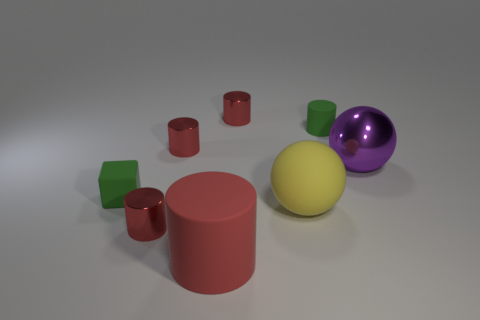Subtract all matte cylinders. How many cylinders are left? 3 Add 1 cyan rubber balls. How many objects exist? 9 Subtract all green cylinders. How many cylinders are left? 4 Subtract all brown spheres. How many red cylinders are left? 4 Subtract 4 cylinders. How many cylinders are left? 1 Subtract all green cylinders. Subtract all gray blocks. How many cylinders are left? 4 Subtract all big green matte blocks. Subtract all yellow rubber balls. How many objects are left? 7 Add 1 big yellow matte things. How many big yellow matte things are left? 2 Add 6 red matte things. How many red matte things exist? 7 Subtract 3 red cylinders. How many objects are left? 5 